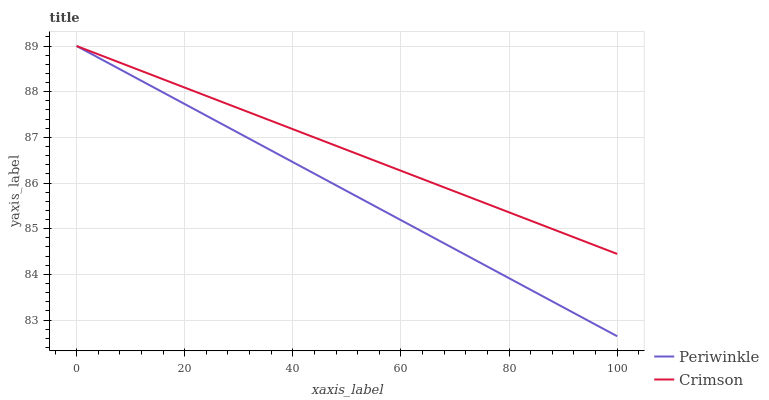Does Periwinkle have the minimum area under the curve?
Answer yes or no. Yes. Does Crimson have the maximum area under the curve?
Answer yes or no. Yes. Does Periwinkle have the maximum area under the curve?
Answer yes or no. No. Is Crimson the smoothest?
Answer yes or no. Yes. Is Periwinkle the roughest?
Answer yes or no. Yes. Is Periwinkle the smoothest?
Answer yes or no. No. 